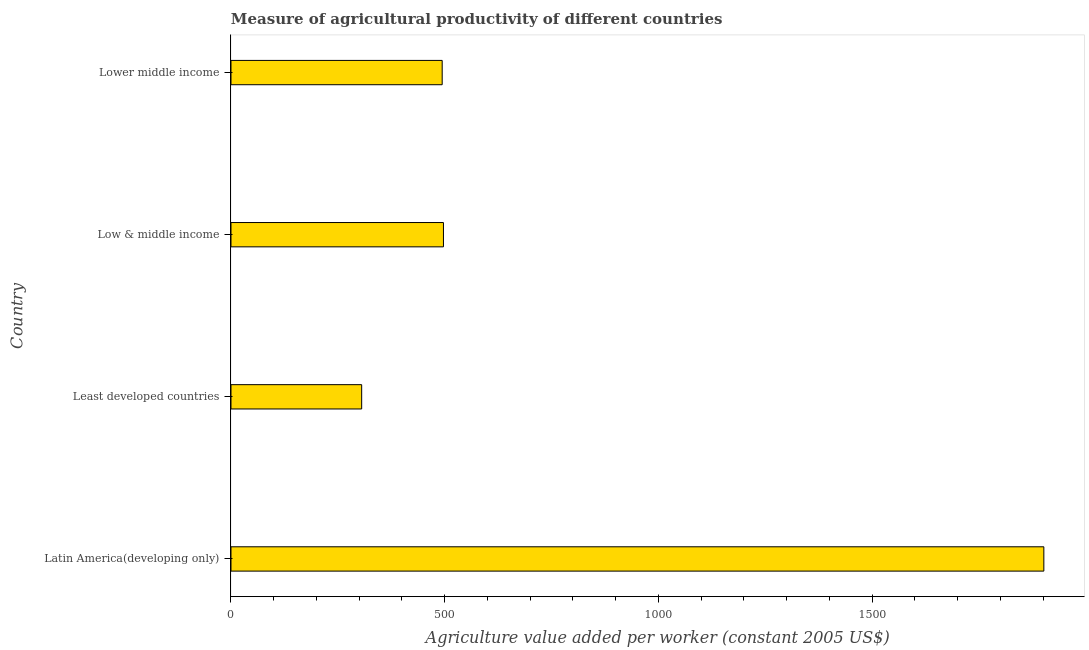What is the title of the graph?
Provide a short and direct response. Measure of agricultural productivity of different countries. What is the label or title of the X-axis?
Provide a short and direct response. Agriculture value added per worker (constant 2005 US$). What is the label or title of the Y-axis?
Your response must be concise. Country. What is the agriculture value added per worker in Lower middle income?
Your answer should be very brief. 494.11. Across all countries, what is the maximum agriculture value added per worker?
Ensure brevity in your answer.  1901.68. Across all countries, what is the minimum agriculture value added per worker?
Make the answer very short. 305.74. In which country was the agriculture value added per worker maximum?
Keep it short and to the point. Latin America(developing only). In which country was the agriculture value added per worker minimum?
Your answer should be very brief. Least developed countries. What is the sum of the agriculture value added per worker?
Offer a terse response. 3198.61. What is the difference between the agriculture value added per worker in Least developed countries and Low & middle income?
Ensure brevity in your answer.  -191.34. What is the average agriculture value added per worker per country?
Ensure brevity in your answer.  799.65. What is the median agriculture value added per worker?
Offer a terse response. 495.59. In how many countries, is the agriculture value added per worker greater than 1400 US$?
Keep it short and to the point. 1. Is the difference between the agriculture value added per worker in Latin America(developing only) and Lower middle income greater than the difference between any two countries?
Your answer should be compact. No. What is the difference between the highest and the second highest agriculture value added per worker?
Give a very brief answer. 1404.6. What is the difference between the highest and the lowest agriculture value added per worker?
Give a very brief answer. 1595.95. How many bars are there?
Offer a terse response. 4. Are all the bars in the graph horizontal?
Ensure brevity in your answer.  Yes. How many countries are there in the graph?
Offer a very short reply. 4. What is the Agriculture value added per worker (constant 2005 US$) in Latin America(developing only)?
Provide a succinct answer. 1901.68. What is the Agriculture value added per worker (constant 2005 US$) in Least developed countries?
Ensure brevity in your answer.  305.74. What is the Agriculture value added per worker (constant 2005 US$) of Low & middle income?
Make the answer very short. 497.08. What is the Agriculture value added per worker (constant 2005 US$) of Lower middle income?
Provide a short and direct response. 494.11. What is the difference between the Agriculture value added per worker (constant 2005 US$) in Latin America(developing only) and Least developed countries?
Give a very brief answer. 1595.95. What is the difference between the Agriculture value added per worker (constant 2005 US$) in Latin America(developing only) and Low & middle income?
Offer a terse response. 1404.6. What is the difference between the Agriculture value added per worker (constant 2005 US$) in Latin America(developing only) and Lower middle income?
Provide a short and direct response. 1407.58. What is the difference between the Agriculture value added per worker (constant 2005 US$) in Least developed countries and Low & middle income?
Your answer should be very brief. -191.34. What is the difference between the Agriculture value added per worker (constant 2005 US$) in Least developed countries and Lower middle income?
Make the answer very short. -188.37. What is the difference between the Agriculture value added per worker (constant 2005 US$) in Low & middle income and Lower middle income?
Provide a succinct answer. 2.98. What is the ratio of the Agriculture value added per worker (constant 2005 US$) in Latin America(developing only) to that in Least developed countries?
Offer a terse response. 6.22. What is the ratio of the Agriculture value added per worker (constant 2005 US$) in Latin America(developing only) to that in Low & middle income?
Keep it short and to the point. 3.83. What is the ratio of the Agriculture value added per worker (constant 2005 US$) in Latin America(developing only) to that in Lower middle income?
Provide a succinct answer. 3.85. What is the ratio of the Agriculture value added per worker (constant 2005 US$) in Least developed countries to that in Low & middle income?
Give a very brief answer. 0.61. What is the ratio of the Agriculture value added per worker (constant 2005 US$) in Least developed countries to that in Lower middle income?
Provide a short and direct response. 0.62. What is the ratio of the Agriculture value added per worker (constant 2005 US$) in Low & middle income to that in Lower middle income?
Your answer should be compact. 1.01. 